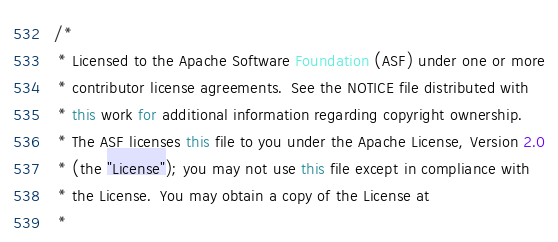<code> <loc_0><loc_0><loc_500><loc_500><_Java_>/*
 * Licensed to the Apache Software Foundation (ASF) under one or more
 * contributor license agreements.  See the NOTICE file distributed with
 * this work for additional information regarding copyright ownership.
 * The ASF licenses this file to you under the Apache License, Version 2.0
 * (the "License"); you may not use this file except in compliance with
 * the License.  You may obtain a copy of the License at
 *</code> 